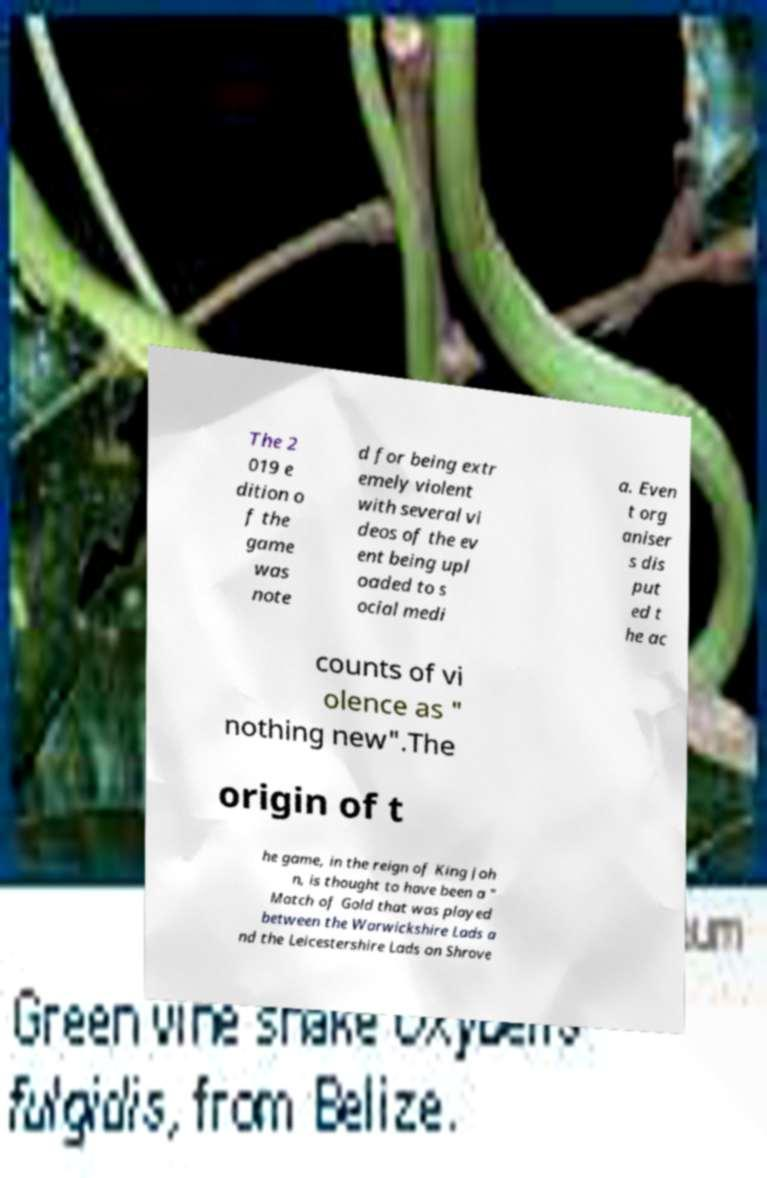For documentation purposes, I need the text within this image transcribed. Could you provide that? The 2 019 e dition o f the game was note d for being extr emely violent with several vi deos of the ev ent being upl oaded to s ocial medi a. Even t org aniser s dis put ed t he ac counts of vi olence as " nothing new".The origin of t he game, in the reign of King Joh n, is thought to have been a " Match of Gold that was played between the Warwickshire Lads a nd the Leicestershire Lads on Shrove 